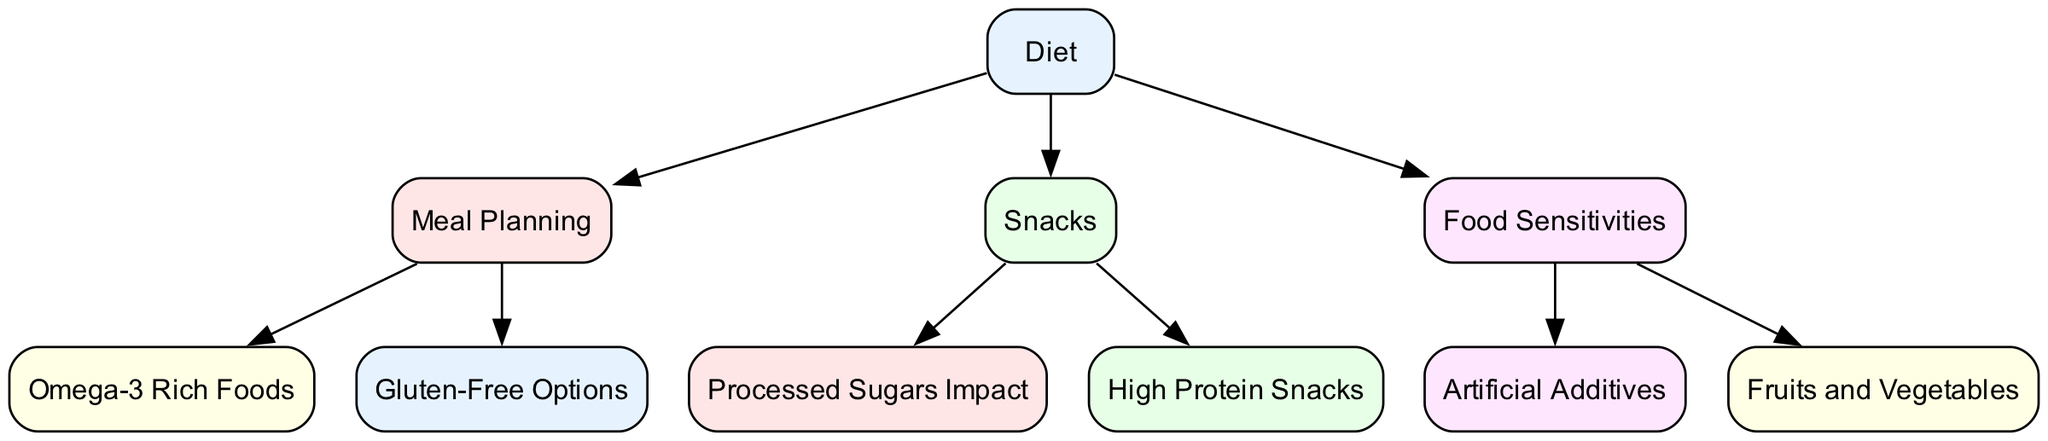What is the central theme of the diagram? The central theme is "Diet," represented at the top of the diagram, indicating its overall impact on the other connected nodes related to Tourette's syndrome.
Answer: Diet How many nodes are there in total? By counting all the unique elements displayed in the diagram, we find a total of 10 distinct nodes are present in the graph.
Answer: 10 Which node is connected to "Snacks"? "Snacks" has connections to "High Protein Snacks" and "Processed Sugars Impact," indicating these are types of snacks related to Tourette's syndrome management.
Answer: High Protein Snacks, Processed Sugars Impact What are two dietary options mentioned under "Meal Planning"? The node "Meal Planning" connects to "Omega-3 Rich Foods" and "Gluten-Free Options," highlighting specific dietary choices that can be made.
Answer: Omega-3 Rich Foods, Gluten-Free Options What does the "Food Sensitivities" node connect to? The "Food Sensitivities" node connects to "Artificial Additives" and "Fruits and Vegetables," suggesting these are dietary factors related to sensitivities affecting symptoms.
Answer: Artificial Additives, Fruits and Vegetables How do "Processed Sugars Impact" and "Artificial Additives" relate to the overall diet? Both are connected to their respective nodes in the diagram, indicating the negative aspects of diet that could worsen symptoms of Tourette's syndrome when included.
Answer: Negative aspects Which category is related to meal planning, snacks, and food sensitivities? All three categories (Meal Planning, Snacks, Food Sensitivities) stem from the central theme "Diet," highlighting their collective relationship in managing symptoms.
Answer: Diet What is the relationship between "Meal Planning" and "Gluten-Free Options"? "Meal Planning" directly connects to "Gluten-Free Options," suggesting that gluten-free meals are a consideration within meal preparation to possibly alleviate Tourette's symptoms.
Answer: Direct connection What is the consequence of "Artificial Additives" in dietary management? "Food Sensitivities" connects to "Artificial Additives," indicating these are potential triggers that might impact symptoms negatively when present in the diet.
Answer: Potential triggers 